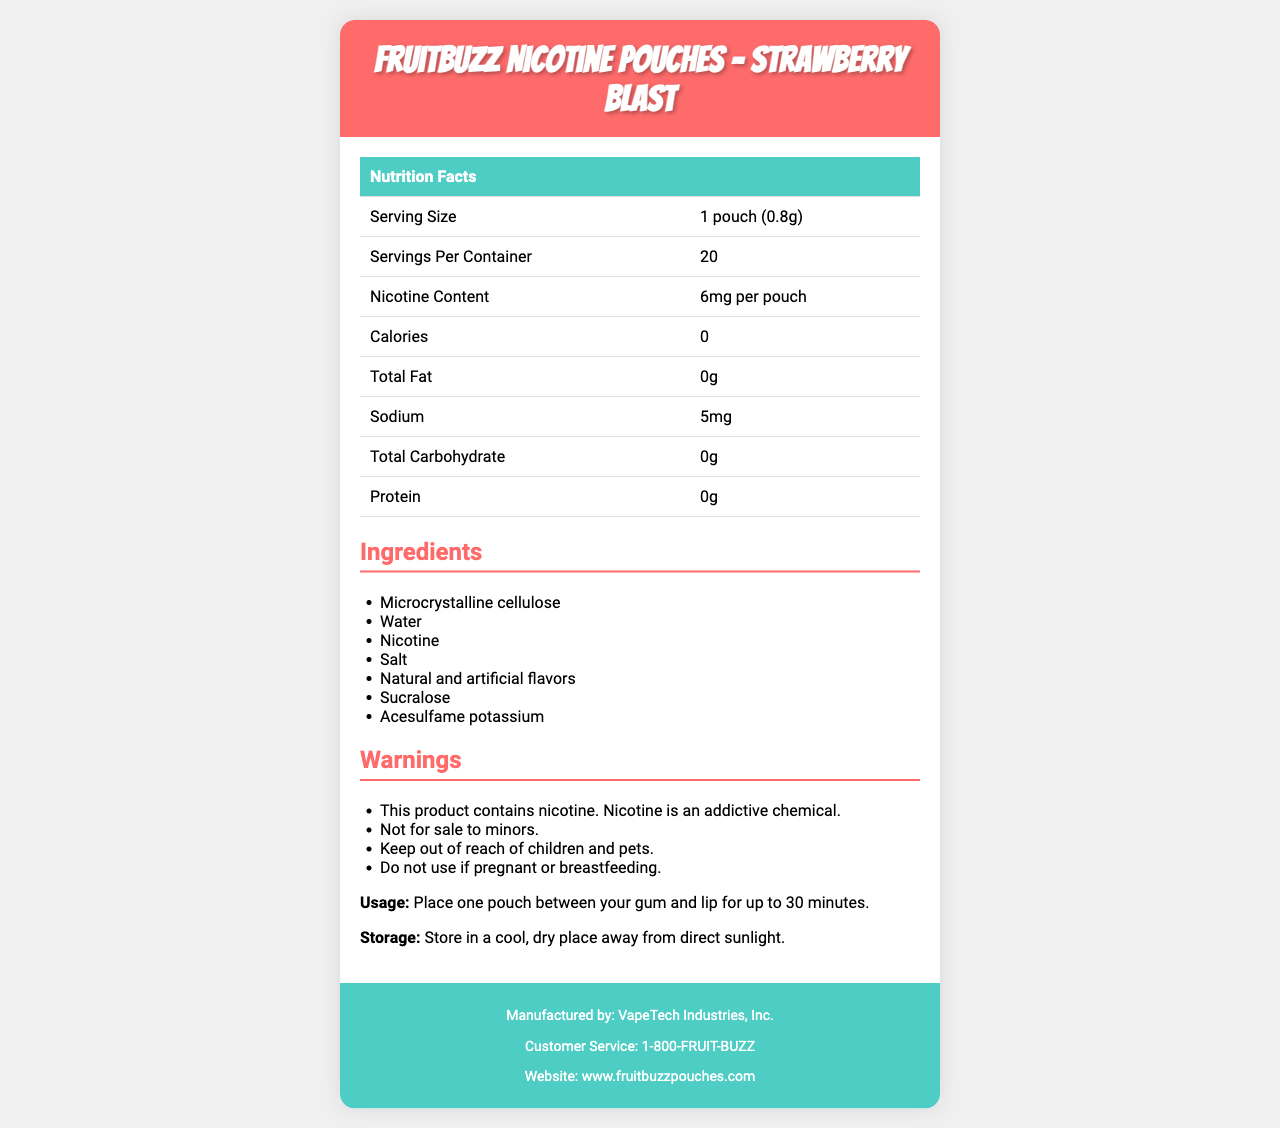what is the serving size? The document states that the serving size is 1 pouch, which weighs 0.8 grams.
Answer: 1 pouch (0.8g) how many servings are in each container? The document mentions that there are 20 servings per container.
Answer: 20 how much nicotine content is in one pouch? The nicotine content is specified as 6mg per pouch in the document.
Answer: 6mg per pouch does the product contain any calories? The nutrition facts table in the document shows 0 calories.
Answer: No what is the sodium content in one serving? The sodium content is listed as 5mg per serving in the document.
Answer: 5mg which ingredient is not natural? The document lists "Natural and artificial flavors," indicating that there are some artificial flavors in the product.
Answer: Artificial flavors what should you do if you are pregnant or breastfeeding? One of the warnings states, "Do not use if pregnant or breastfeeding."
Answer: Do not use how long should you keep a pouch between your gum and lip? The document specifies that you should place one pouch between your gum and lip for up to 30 minutes.
Answer: Up to 30 minutes what is the best way to store the product? The storage instructions mention storing the product in a cool, dry place away from direct sunlight.
Answer: In a cool, dry place away from direct sunlight what are the total carbohydrates in one serving? The nutrition facts indicate that there are no carbohydrates (0g) in one serving.
Answer: 0g who manufactures the product? According to the footer of the document, the manufacturer is VapeTech Industries, Inc.
Answer: VapeTech Industries, Inc. what is the customer service phone number? The customer service phone number listed in the footer is 1-800-FRUIT-BUZZ.
Answer: 1-800-FRUIT-BUZZ which of the following is an artificial sweetener in the ingredients? A. Microcrystalline cellulose B. Water C. Sucralose D. Salt Sucralose is an artificial sweetener listed in the ingredients.
Answer: C. Sucralose what type of flavors are included in the product? A. Only natural flavors B. Only artificial flavors C. Both natural and artificial flavors D. No flavors The ingredients section lists both natural and artificial flavors.
Answer: C. Both natural and artificial flavors is this product intended for sale to minors? (yes/no) The warnings clearly state that the product is "Not for sale to minors."
Answer: No what are the main cautions mentioned in the warnings section? The warnings section lists these main cautions regarding the product.
Answer: Contains nicotine, not for minors, keep out of reach of children and pets, do not use if pregnant or breastfeeding can you determine the exact age restriction for purchasing this product? The document states "Not for sale to minors" but does not specify a specific age restriction.
Answer: Not enough information please summarize the key points of the document. The summary efficiently captures the essential features and cautions of the product documented in the provided visual details.
Answer: The document provides the nutrition facts, ingredients, warnings, usage instructions, storage recommendations, and contact information for FruitBuzz Nicotine Pouches - Strawberry Blast. Each pouch contains 6mg nicotine, and there are 20 servings per container. The product contains no calories, fat, carbohydrates, or protein. The key ingredients include microcrystalline cellulose, nicotine, and various artificial flavors and sweeteners. Important warnings highlight the product's nicotine content and its restrictions for children, pets, pregnant or breastfeeding women, and minors. The product should be stored in a cool, dry place. Customer service and manufacturer details are also provided. 